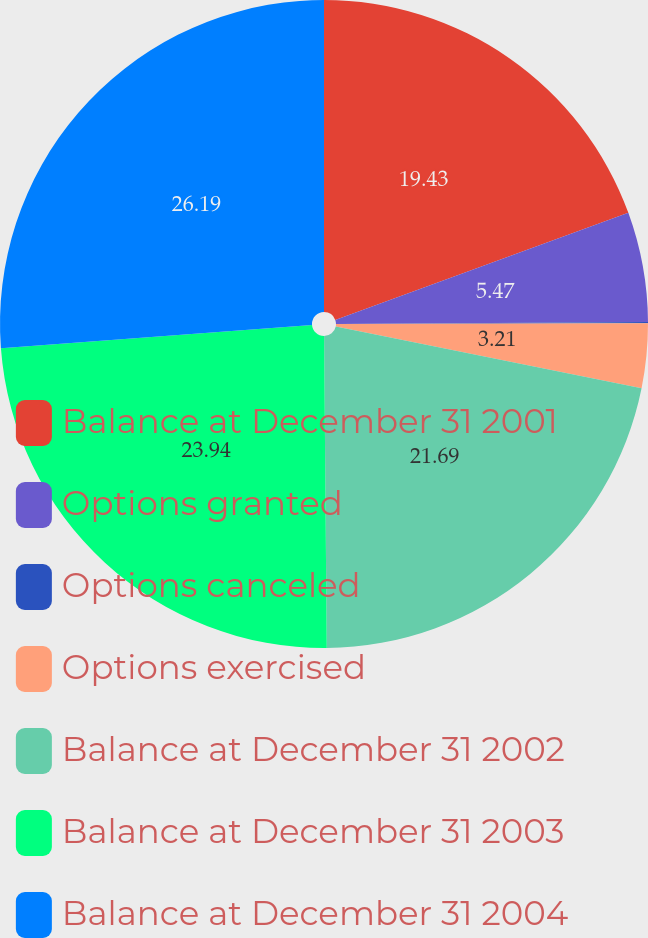<chart> <loc_0><loc_0><loc_500><loc_500><pie_chart><fcel>Balance at December 31 2001<fcel>Options granted<fcel>Options canceled<fcel>Options exercised<fcel>Balance at December 31 2002<fcel>Balance at December 31 2003<fcel>Balance at December 31 2004<nl><fcel>19.43%<fcel>5.47%<fcel>0.07%<fcel>3.21%<fcel>21.69%<fcel>23.94%<fcel>26.2%<nl></chart> 